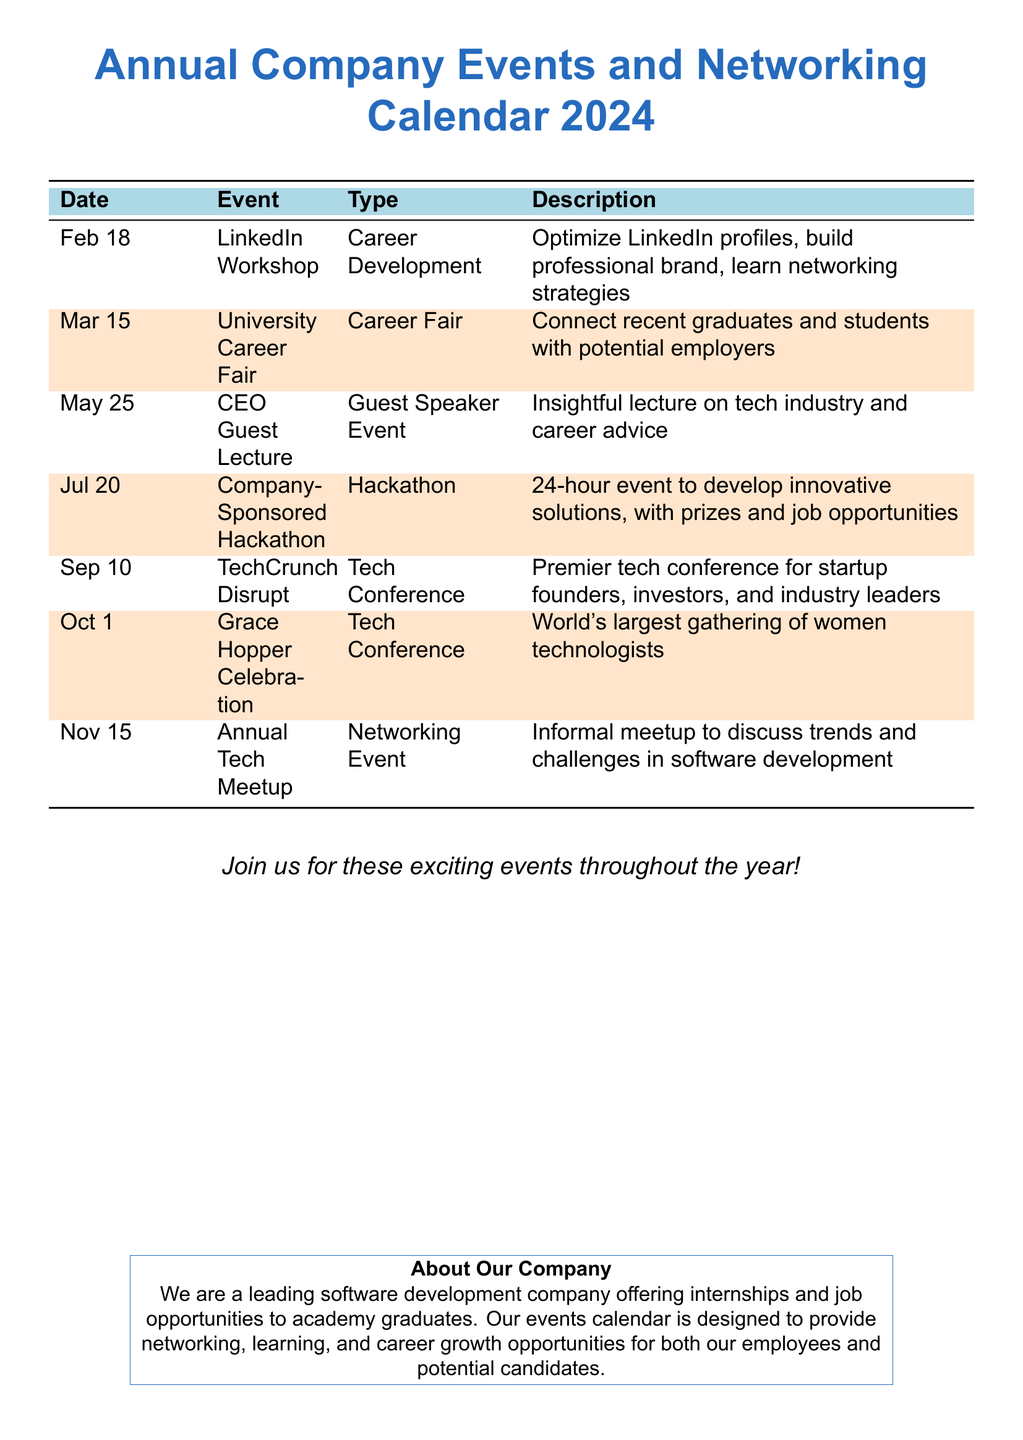What is the date of the LinkedIn Workshop? The LinkedIn Workshop is scheduled for February 18.
Answer: February 18 What type of event is the Grace Hopper Celebration? The Grace Hopper Celebration is classified as a Tech Conference.
Answer: Tech Conference What is the focus of the CEO Guest Lecture? The focus is on providing insight into the tech industry and career advice.
Answer: Insightful lecture on tech industry and career advice Which event provides job opportunities? The Company-Sponsored Hackathon offers job opportunities.
Answer: Company-Sponsored Hackathon How many tech conferences are listed in the calendar? There are two tech conferences mentioned: TechCrunch Disrupt and Grace Hopper Celebration.
Answer: 2 What is the unique feature of the Company-Sponsored Hackathon? It is a 24-hour event to develop innovative solutions.
Answer: 24-hour event When does the Annual Tech Meetup take place? The Annual Tech Meetup is scheduled for November 15.
Answer: November 15 What type of event is the University Career Fair? The University Career Fair is a Career Fair.
Answer: Career Fair Which month features the most events in the calendar? July features the most events with the Company-Sponsored Hackathon.
Answer: July 